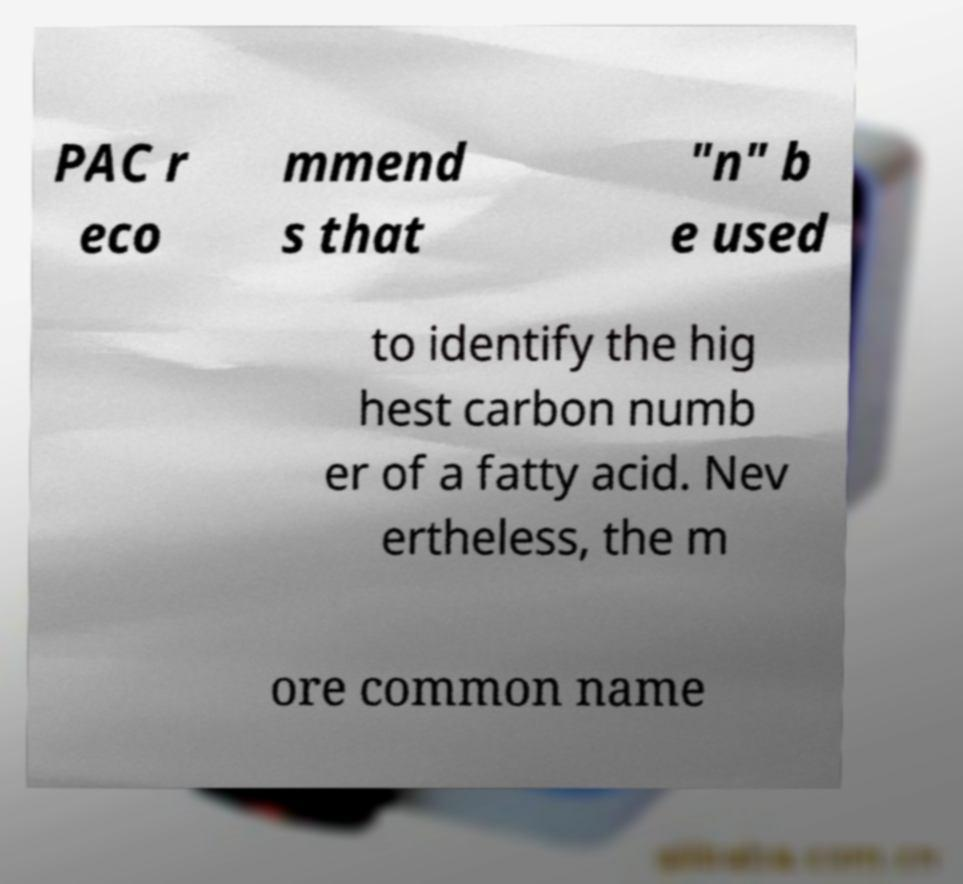Could you assist in decoding the text presented in this image and type it out clearly? PAC r eco mmend s that "n" b e used to identify the hig hest carbon numb er of a fatty acid. Nev ertheless, the m ore common name 